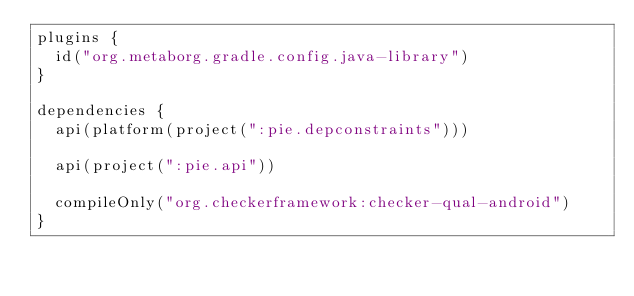Convert code to text. <code><loc_0><loc_0><loc_500><loc_500><_Kotlin_>plugins {
  id("org.metaborg.gradle.config.java-library")
}

dependencies {
  api(platform(project(":pie.depconstraints")))
  
  api(project(":pie.api"))
  
  compileOnly("org.checkerframework:checker-qual-android")
}
</code> 